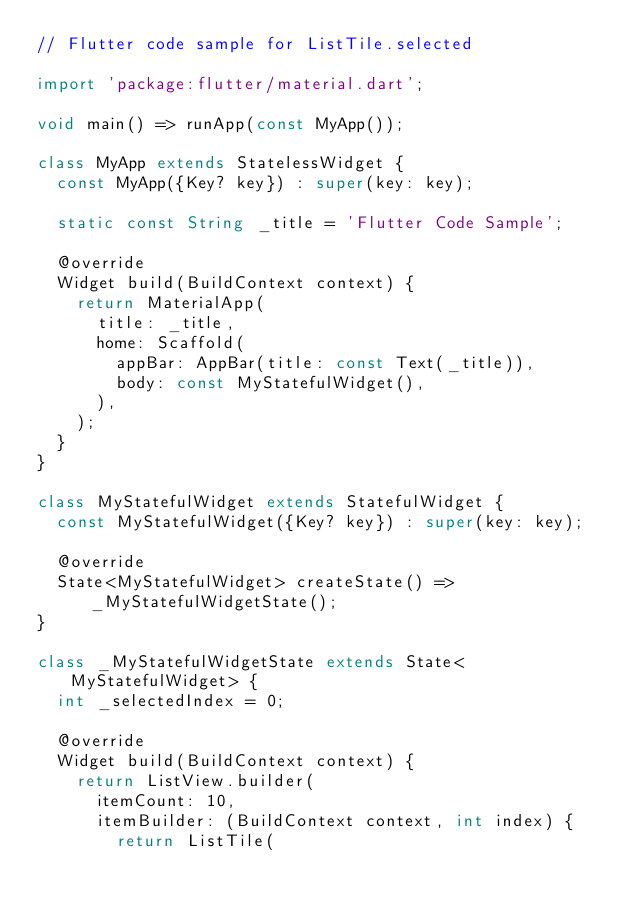<code> <loc_0><loc_0><loc_500><loc_500><_Dart_>// Flutter code sample for ListTile.selected

import 'package:flutter/material.dart';

void main() => runApp(const MyApp());

class MyApp extends StatelessWidget {
  const MyApp({Key? key}) : super(key: key);

  static const String _title = 'Flutter Code Sample';

  @override
  Widget build(BuildContext context) {
    return MaterialApp(
      title: _title,
      home: Scaffold(
        appBar: AppBar(title: const Text(_title)),
        body: const MyStatefulWidget(),
      ),
    );
  }
}

class MyStatefulWidget extends StatefulWidget {
  const MyStatefulWidget({Key? key}) : super(key: key);

  @override
  State<MyStatefulWidget> createState() => _MyStatefulWidgetState();
}

class _MyStatefulWidgetState extends State<MyStatefulWidget> {
  int _selectedIndex = 0;

  @override
  Widget build(BuildContext context) {
    return ListView.builder(
      itemCount: 10,
      itemBuilder: (BuildContext context, int index) {
        return ListTile(</code> 